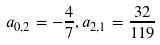<formula> <loc_0><loc_0><loc_500><loc_500>a _ { 0 , 2 } = - \frac { 4 } { 7 } , a _ { 2 , 1 } = \frac { 3 2 } { 1 1 9 }</formula> 